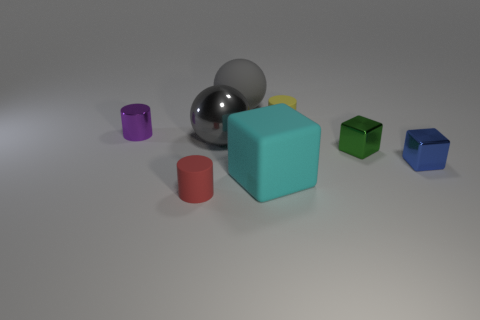What number of other objects are there of the same size as the red cylinder?
Provide a succinct answer. 4. There is a big gray thing that is behind the small rubber object to the right of the red rubber cylinder; is there a small rubber cylinder that is right of it?
Give a very brief answer. Yes. What is the size of the purple thing?
Offer a terse response. Small. There is a rubber cylinder that is behind the tiny blue metal block; what size is it?
Ensure brevity in your answer.  Small. Do the object that is to the left of the red rubber thing and the red rubber thing have the same size?
Offer a very short reply. Yes. Are there any other things of the same color as the rubber ball?
Your response must be concise. Yes. What is the shape of the small purple metallic thing?
Your response must be concise. Cylinder. What number of things are both in front of the yellow cylinder and left of the yellow object?
Make the answer very short. 4. Is the color of the big shiny object the same as the metal cylinder?
Offer a terse response. No. There is a cyan object that is the same shape as the blue shiny thing; what is its material?
Provide a short and direct response. Rubber. 